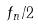<formula> <loc_0><loc_0><loc_500><loc_500>f _ { n } / 2</formula> 